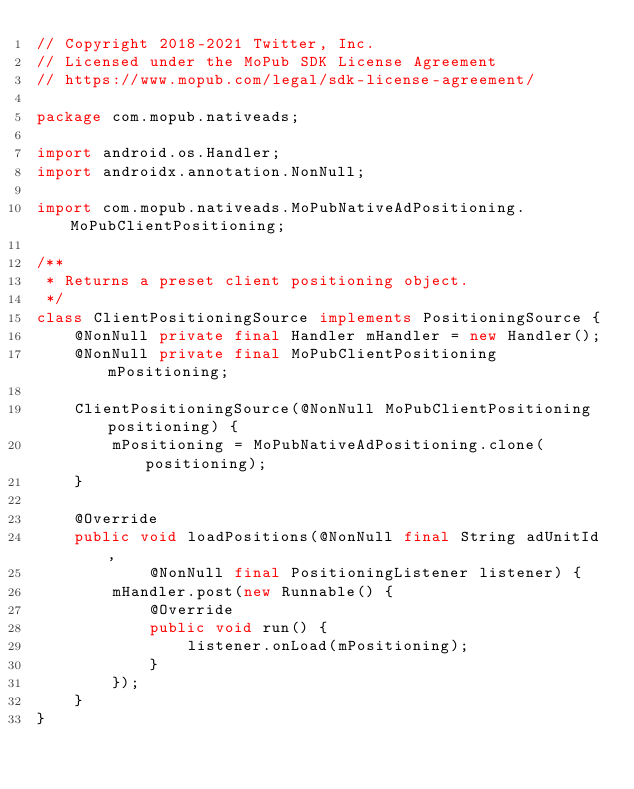<code> <loc_0><loc_0><loc_500><loc_500><_Java_>// Copyright 2018-2021 Twitter, Inc.
// Licensed under the MoPub SDK License Agreement
// https://www.mopub.com/legal/sdk-license-agreement/

package com.mopub.nativeads;

import android.os.Handler;
import androidx.annotation.NonNull;

import com.mopub.nativeads.MoPubNativeAdPositioning.MoPubClientPositioning;

/**
 * Returns a preset client positioning object.
 */
class ClientPositioningSource implements PositioningSource {
    @NonNull private final Handler mHandler = new Handler();
    @NonNull private final MoPubClientPositioning mPositioning;

    ClientPositioningSource(@NonNull MoPubClientPositioning positioning) {
        mPositioning = MoPubNativeAdPositioning.clone(positioning);
    }

    @Override
    public void loadPositions(@NonNull final String adUnitId,
            @NonNull final PositioningListener listener) {
        mHandler.post(new Runnable() {
            @Override
            public void run() {
                listener.onLoad(mPositioning);
            }
        });
    }
}
</code> 